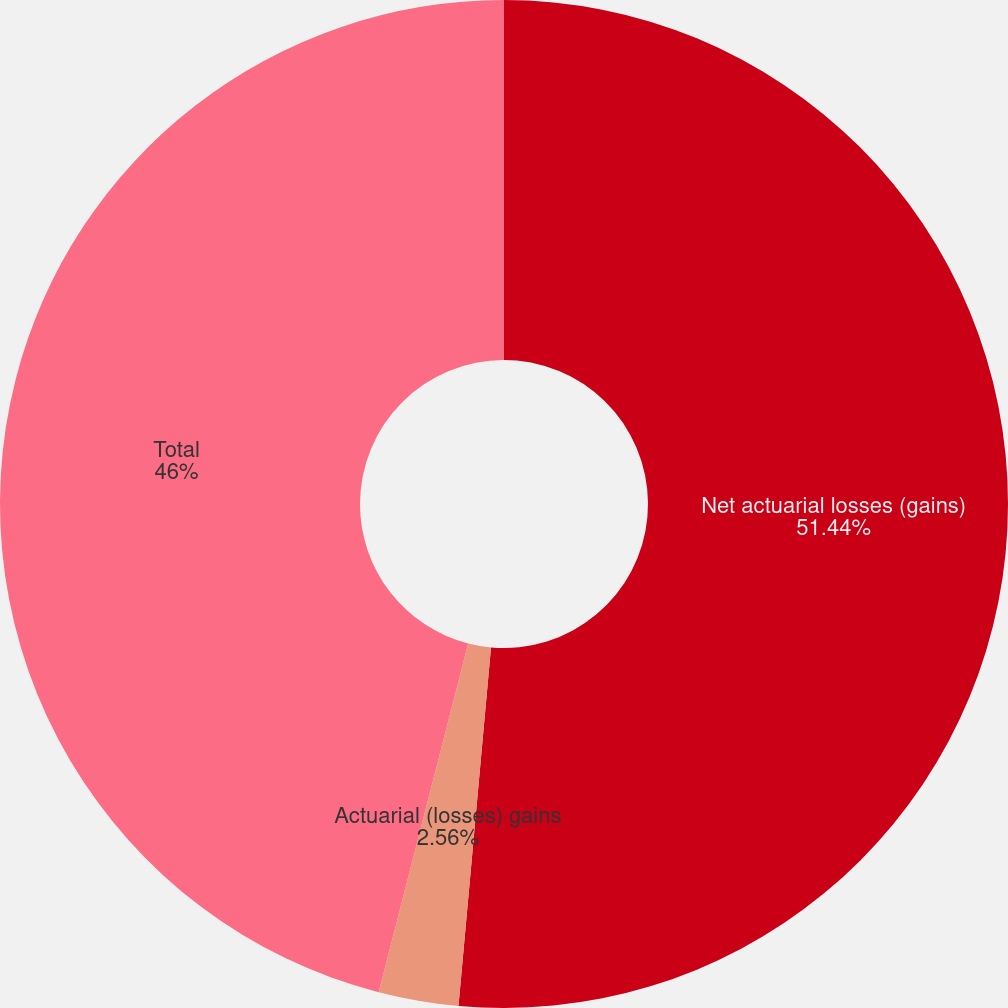<chart> <loc_0><loc_0><loc_500><loc_500><pie_chart><fcel>Net actuarial losses (gains)<fcel>Actuarial (losses) gains<fcel>Total<nl><fcel>51.44%<fcel>2.56%<fcel>46.0%<nl></chart> 